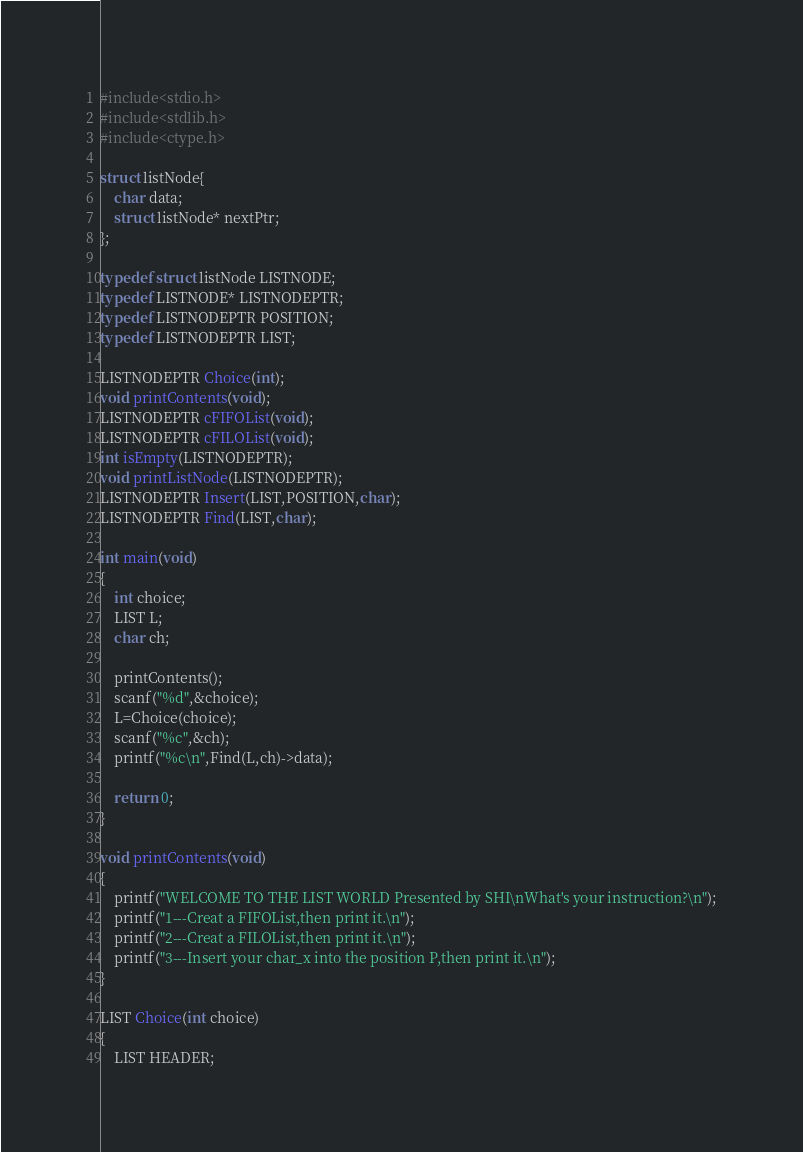Convert code to text. <code><loc_0><loc_0><loc_500><loc_500><_C_>#include<stdio.h>
#include<stdlib.h>
#include<ctype.h>

struct listNode{
	char data;
	struct listNode* nextPtr;
};

typedef struct listNode LISTNODE; 
typedef LISTNODE* LISTNODEPTR;
typedef LISTNODEPTR POSITION;
typedef LISTNODEPTR LIST;

LISTNODEPTR Choice(int);
void printContents(void);
LISTNODEPTR cFIFOList(void);
LISTNODEPTR cFILOList(void);
int isEmpty(LISTNODEPTR);
void printListNode(LISTNODEPTR);
LISTNODEPTR Insert(LIST,POSITION,char);
LISTNODEPTR Find(LIST,char);

int main(void)
{
	int choice;
	LIST L;
	char ch;
	
	printContents();
	scanf("%d",&choice);
	L=Choice(choice);
	scanf("%c",&ch);
	printf("%c\n",Find(L,ch)->data);
	
	return 0;
}

void printContents(void)
{
	printf("WELCOME TO THE LIST WORLD Presented by SHI\nWhat's your instruction?\n");
	printf("1---Creat a FIFOList,then print it.\n");
	printf("2---Creat a FILOList,then print it.\n");
	printf("3---Insert your char_x into the position P,then print it.\n");
}

LIST Choice(int choice)
{
	LIST HEADER;</code> 